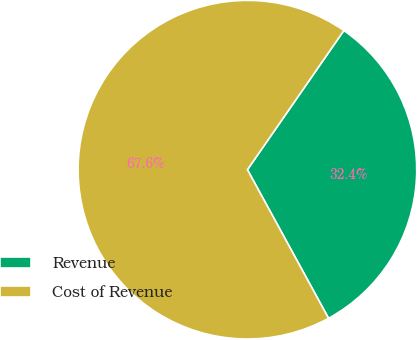Convert chart. <chart><loc_0><loc_0><loc_500><loc_500><pie_chart><fcel>Revenue<fcel>Cost of Revenue<nl><fcel>32.4%<fcel>67.6%<nl></chart> 